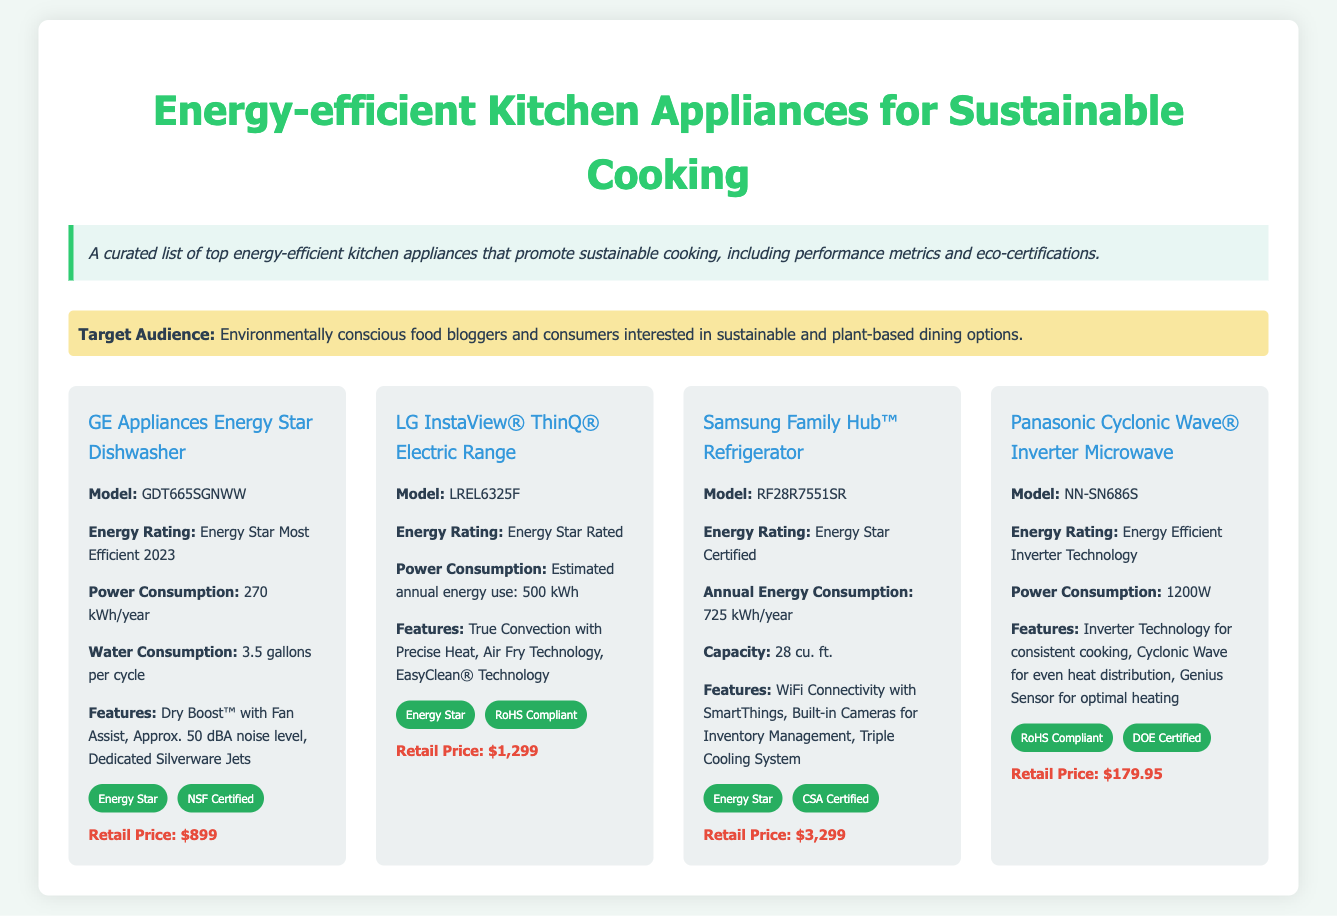What is the energy rating of the GE Appliances Energy Star Dishwasher? The energy rating is described in the document as "Energy Star Most Efficient 2023."
Answer: Energy Star Most Efficient 2023 What is the water consumption of the LG InstaView® ThinQ® Electric Range? The document states that the estimated annual energy use is 500 kWh; there is no water consumption stated for the range.
Answer: Not applicable How much does the Samsung Family Hub™ Refrigerator retail for? The retail price for the refrigerator is mentioned in the document.
Answer: $3,299 What certification does the Panasonic Cyclonic Wave® Inverter Microwave have? The microwave has "RoHS Compliant" and "DOE Certified" as its eco certifications listed in the document.
Answer: RoHS Compliant, DOE Certified Which appliance has the lowest power consumption? The GE Appliances Energy Star Dishwasher is listed with a power consumption of 270 kWh/year, which is the lowest when compared to others.
Answer: 270 kWh/year What unique feature does the LG InstaView® ThinQ® Electric Range offer? The document lists several features, one of which is "Air Fry Technology."
Answer: Air Fry Technology How many eco certifications does the Samsung Family Hub™ Refrigerator have? The document specifies that it has two eco certifications: "Energy Star" and "CSA Certified."
Answer: 2 What is the annual energy consumption of the Panasonic Cyclonic Wave® Inverter Microwave? The document indicates that its power consumption is 1200W, which implies the energy consumption over a year isn't directly stated.
Answer: Not applicable 